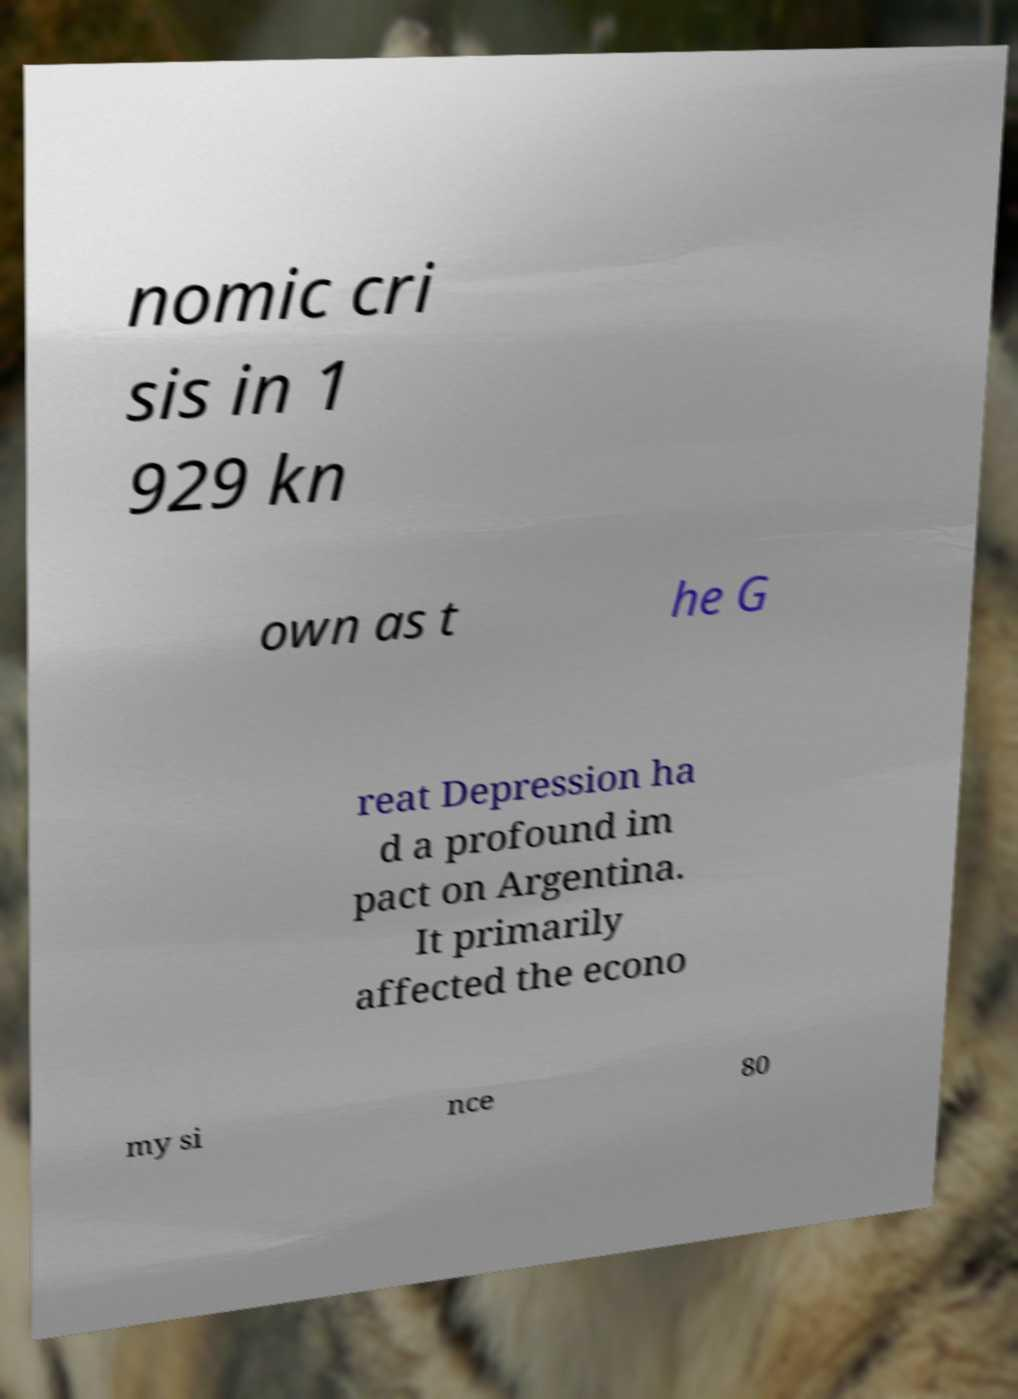Can you read and provide the text displayed in the image?This photo seems to have some interesting text. Can you extract and type it out for me? nomic cri sis in 1 929 kn own as t he G reat Depression ha d a profound im pact on Argentina. It primarily affected the econo my si nce 80 